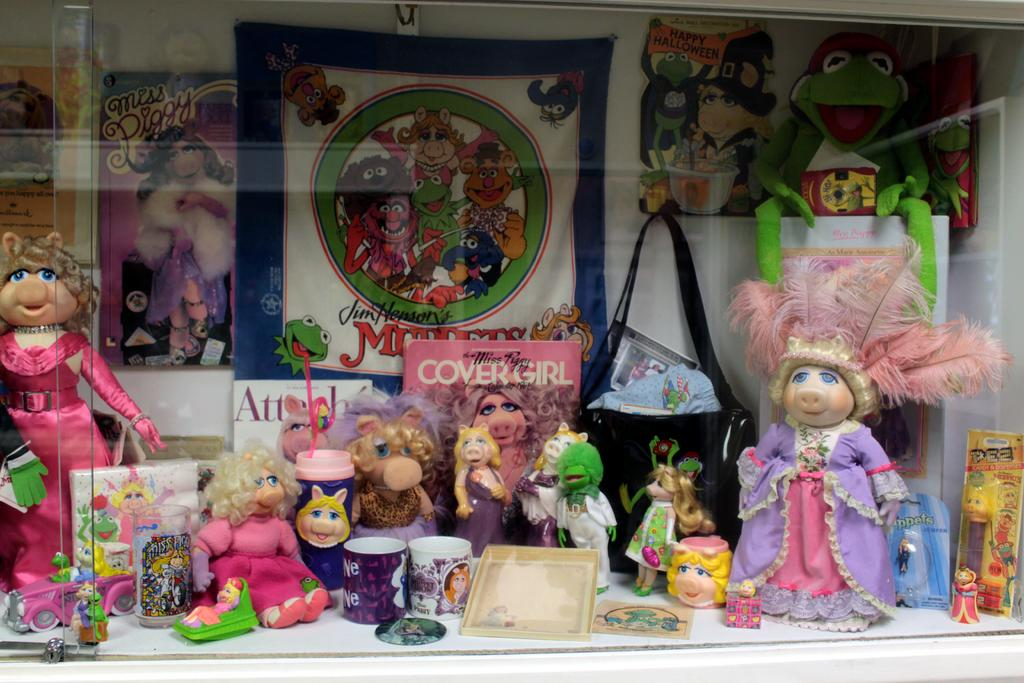Provide a one-sentence caption for the provided image. A display of various Miss Piggy figures and items. 